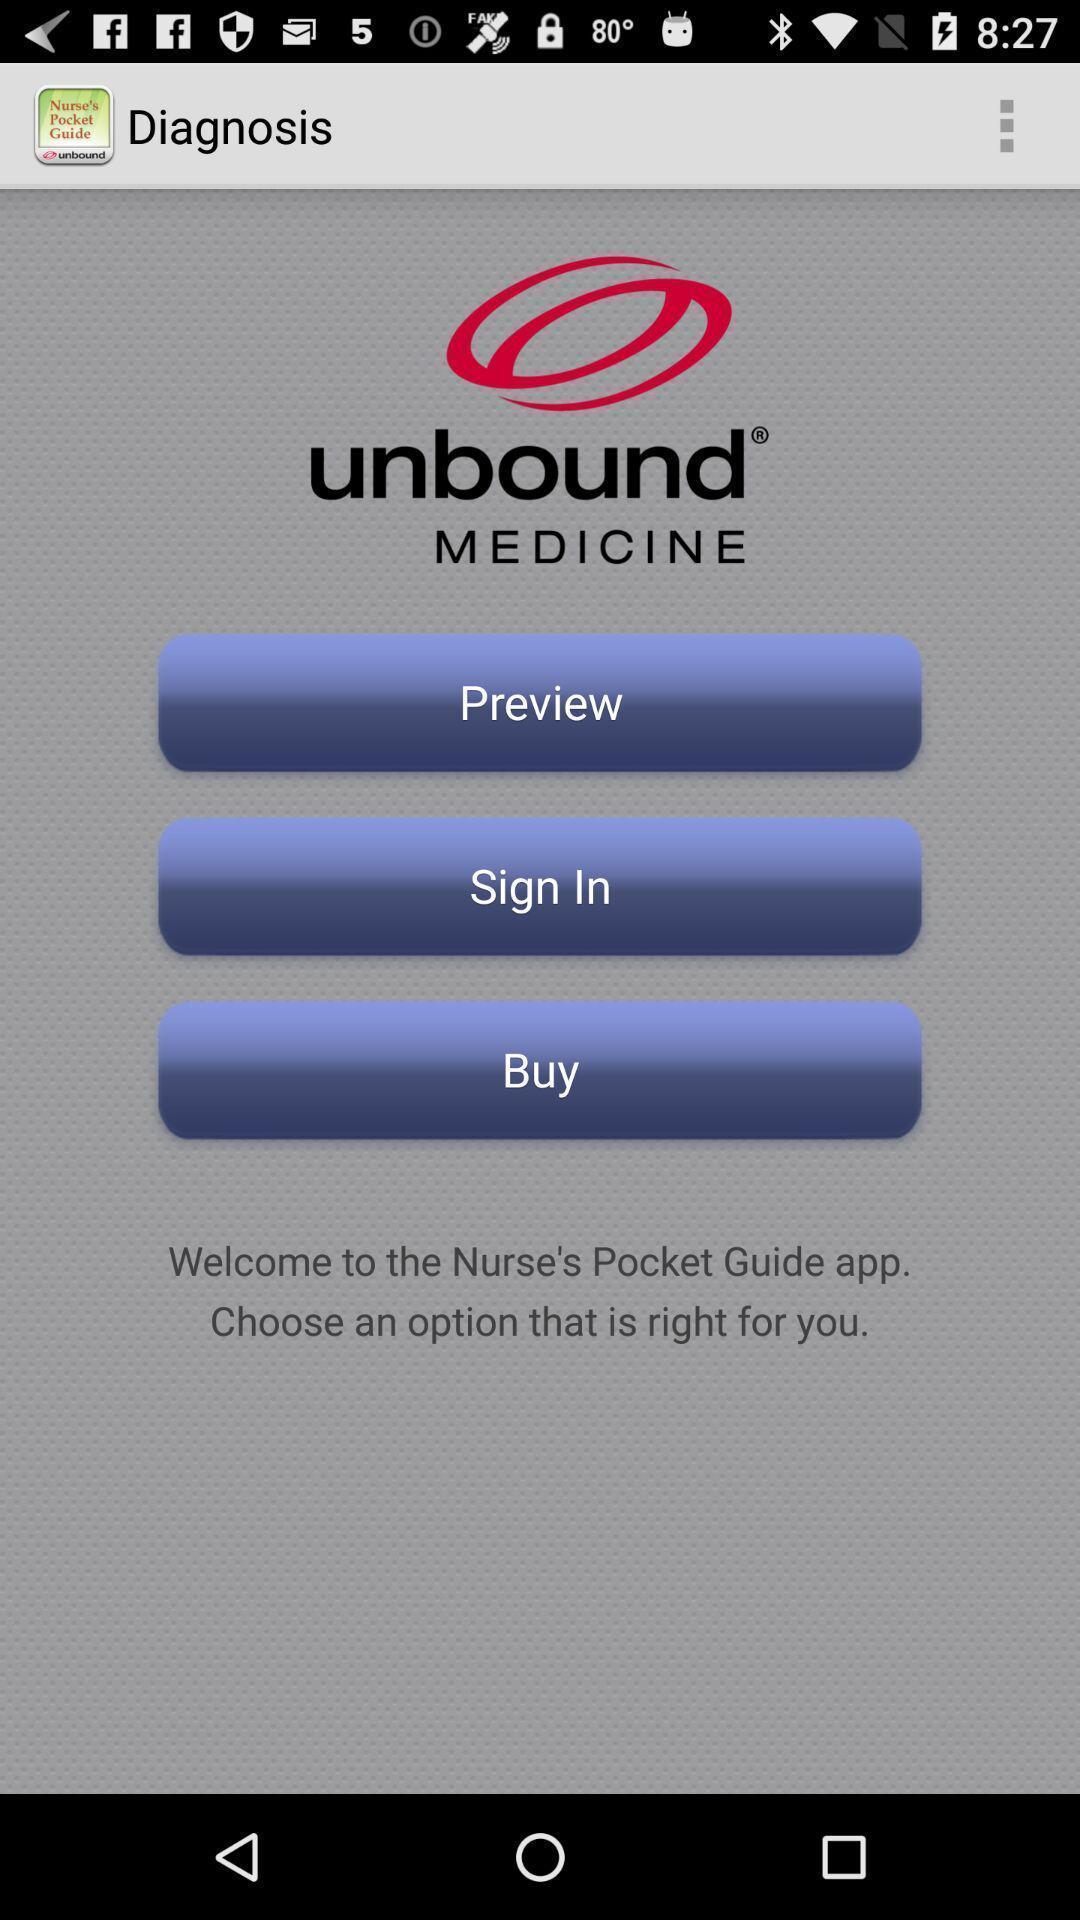Describe the content in this image. Welcome page of a learning app. 